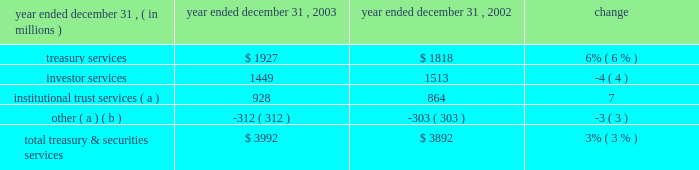J.p .
Morgan chase & co .
/ 2003 annual report 33 corporate credit allocation in 2003 , tss was assigned a corporate credit allocation of pre- tax earnings and the associated capital related to certain credit exposures managed within ib 2019s credit portfolio on behalf of clients shared with tss .
Prior periods have been revised to reflect this allocation .
For 2003 , the impact to tss of this change increased pre-tax operating results by $ 36 million and average allocated capital by $ 712 million , and it decreased sva by $ 65 million .
Pre-tax operating results were $ 46 million lower than in 2002 , reflecting lower loan volumes and higher related expenses , slightly offset by a decrease in credit costs .
Business outlook tss revenue in 2004 is expected to benefit from improved global equity markets and from two recent acquisitions : the november 2003 acquisition of the bank one corporate trust portfolio , and the january 2004 acquisition of citigroup 2019s electronic funds services business .
Tss also expects higher costs as it integrates these acquisitions and continues strategic investments to sup- port business expansion .
By client segment tss dimensions of 2003 revenue diversification by business revenue by geographic region investor services 36% ( 36 % ) other 1% ( 1 % ) institutional trust services 23% ( 23 % ) treasury services 40% ( 40 % ) large corporations 21% ( 21 % ) middle market 18% ( 18 % ) banks 11% ( 11 % ) nonbank financial institutions 44% ( 44 % ) public sector/governments 6% ( 6 % ) europe , middle east & africa 27% ( 27 % ) asia/pacific 9% ( 9 % ) the americas 64% ( 64 % ) ( a ) includes the elimination of revenue related to shared activities with chase middle market in the amount of $ 347 million .
Year ended december 31 , operating revenue .
( a ) includes a portion of the $ 41 million gain on sale of a nonstrategic business in 2003 : $ 1 million in institutional trust services and $ 40 million in other .
( b ) includes the elimination of revenues related to shared activities with chase middle market , and a $ 50 million gain on sale of a non-u.s .
Securities clearing firm in 2002. .
In 2003 what was the ratio of the investor services to treasury services revenues? 
Computations: (1449 / 1927)
Answer: 0.75195. 